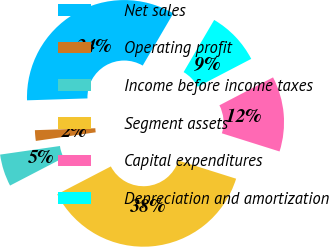<chart> <loc_0><loc_0><loc_500><loc_500><pie_chart><fcel>Net sales<fcel>Operating profit<fcel>Income before income taxes<fcel>Segment assets<fcel>Capital expenditures<fcel>Depreciation and amortization<nl><fcel>33.94%<fcel>1.77%<fcel>5.35%<fcel>37.52%<fcel>12.5%<fcel>8.92%<nl></chart> 